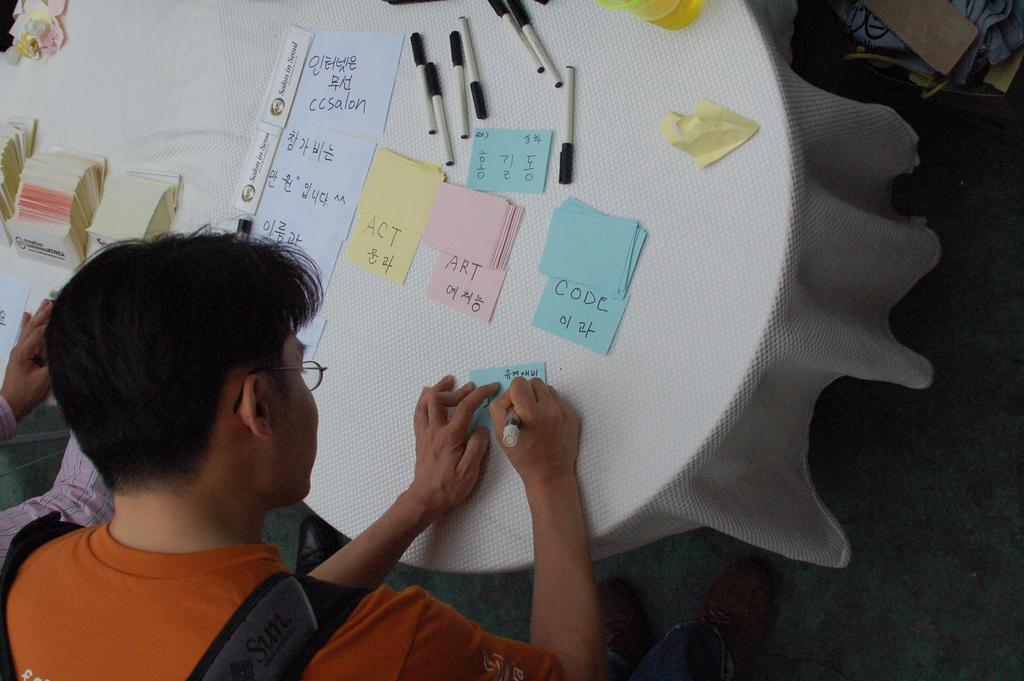What is the main piece of furniture in the image? There is a table in the image. What items can be seen on the table? Papers, pens, and a glass are visible on the table. What are the two people in the image doing? The two people are standing in the image and writing on papers placed on the table. How many cents are visible on the table in the image? There are no cents present on the table in the image. Can you tell me how the mother is helping the two people in the image? There is no mention of a mother in the image, and therefore no such interaction can be observed. 